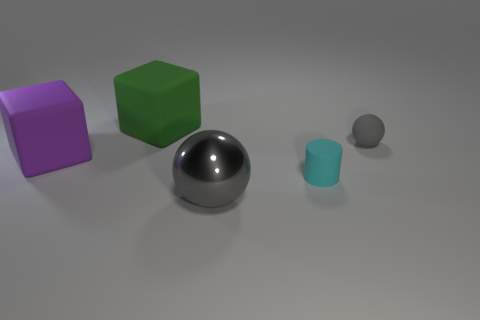What might be the sizes of the blocks relative to each other? The blocks, while both appearing to be cubes, differ in size. The purple block is larger compared to the green block, implying a variance in scale between them. 